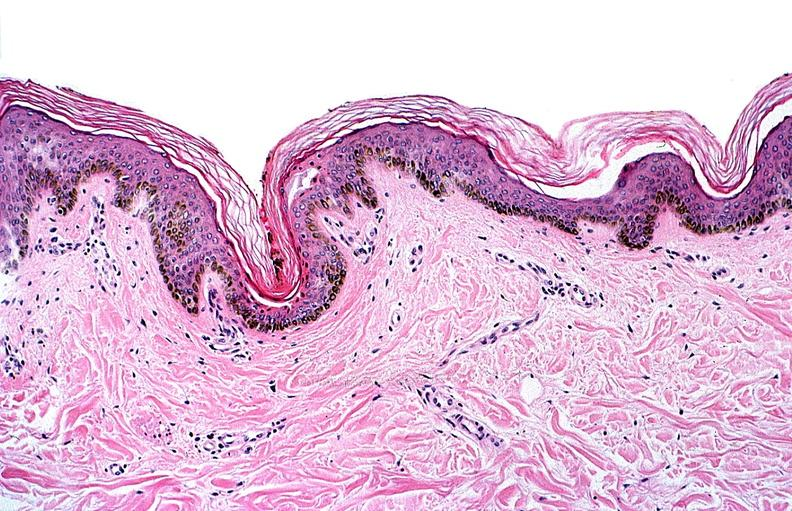what does this image show?
Answer the question using a single word or phrase. Thermal burned skin 